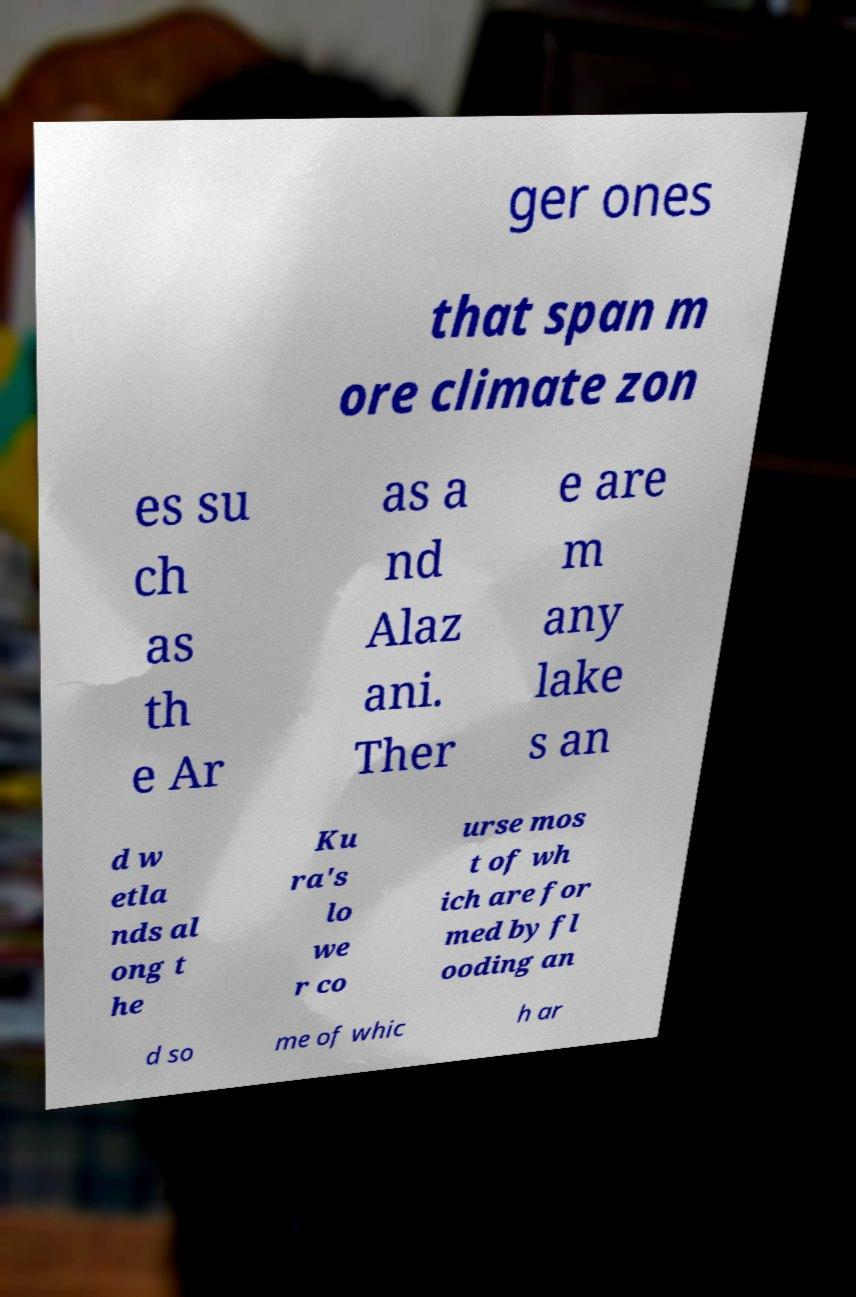Could you extract and type out the text from this image? ger ones that span m ore climate zon es su ch as th e Ar as a nd Alaz ani. Ther e are m any lake s an d w etla nds al ong t he Ku ra's lo we r co urse mos t of wh ich are for med by fl ooding an d so me of whic h ar 